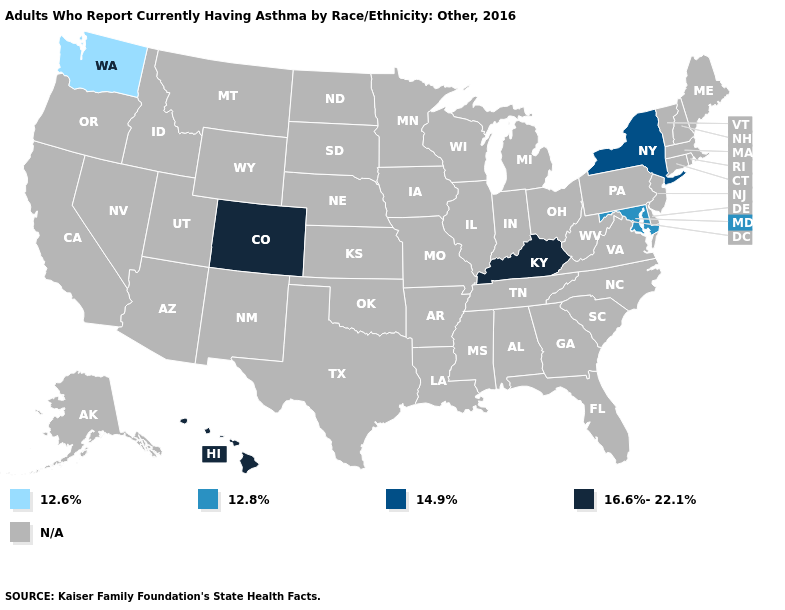Does Maryland have the lowest value in the South?
Concise answer only. Yes. What is the value of Georgia?
Quick response, please. N/A. Does Colorado have the lowest value in the USA?
Write a very short answer. No. Name the states that have a value in the range 16.6%-22.1%?
Keep it brief. Colorado, Hawaii, Kentucky. Name the states that have a value in the range 12.6%?
Short answer required. Washington. Is the legend a continuous bar?
Short answer required. No. What is the value of Indiana?
Quick response, please. N/A. Does Hawaii have the lowest value in the West?
Keep it brief. No. Name the states that have a value in the range 14.9%?
Short answer required. New York. What is the value of New Hampshire?
Be succinct. N/A. 